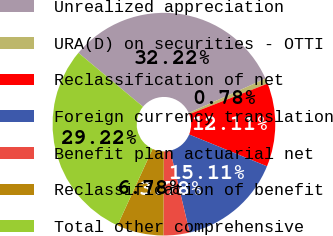Convert chart to OTSL. <chart><loc_0><loc_0><loc_500><loc_500><pie_chart><fcel>Unrealized appreciation<fcel>URA(D) on securities - OTTI<fcel>Reclassification of net<fcel>Foreign currency translation<fcel>Benefit plan actuarial net<fcel>Reclassification of benefit<fcel>Total other comprehensive<nl><fcel>32.22%<fcel>0.78%<fcel>12.11%<fcel>15.11%<fcel>3.78%<fcel>6.78%<fcel>29.22%<nl></chart> 